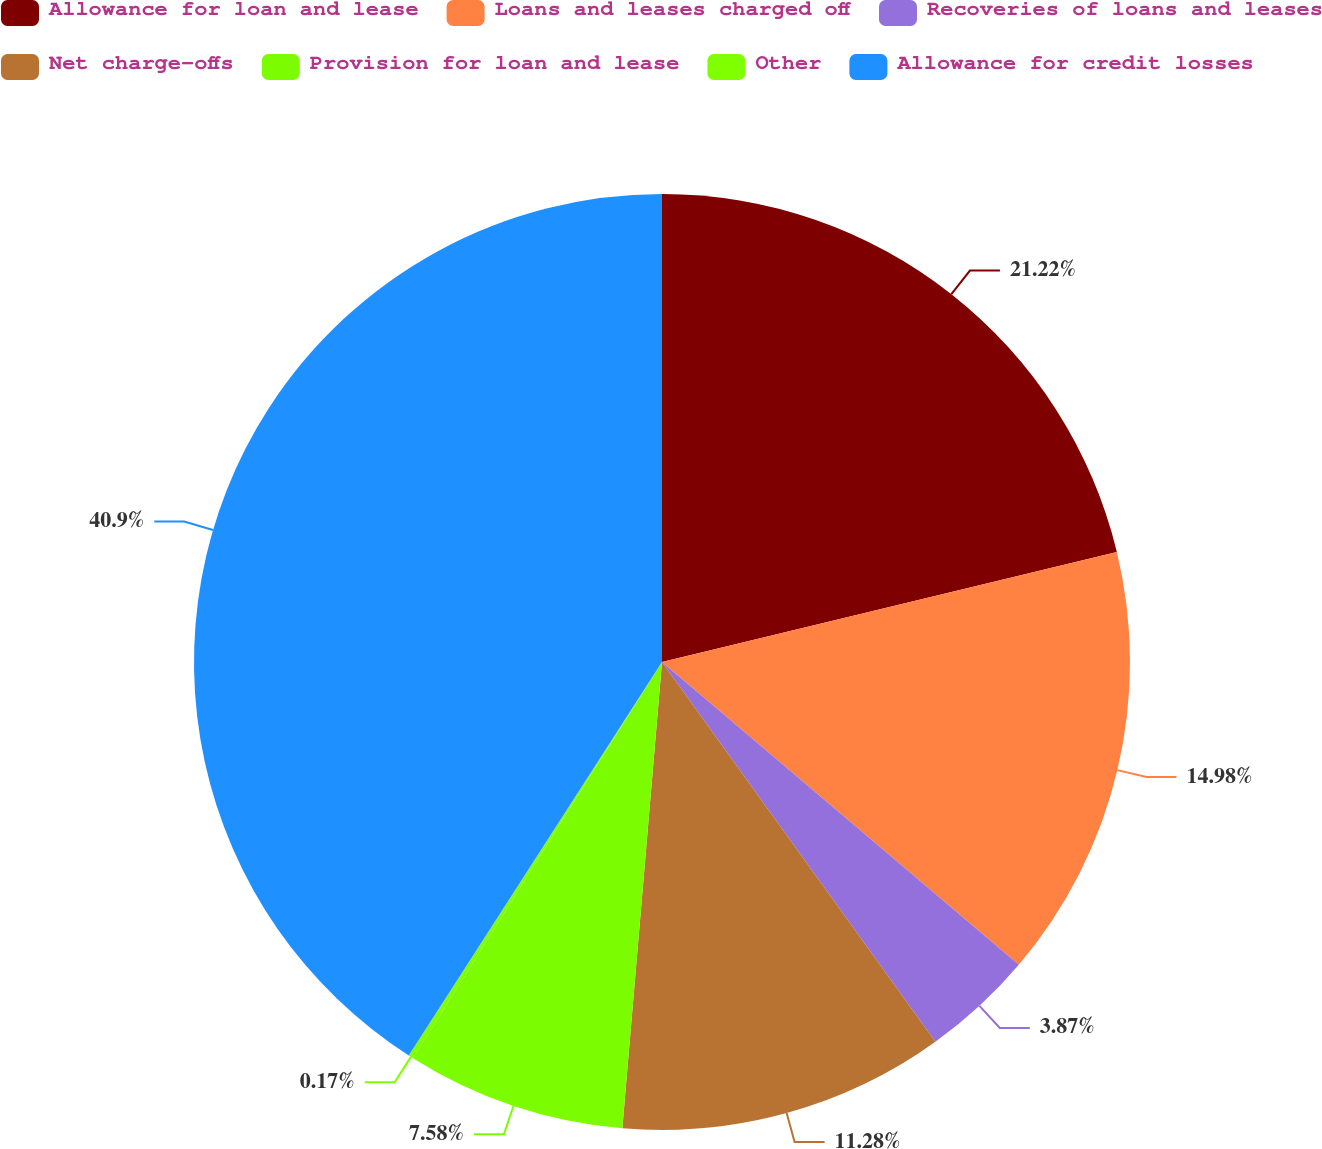Convert chart to OTSL. <chart><loc_0><loc_0><loc_500><loc_500><pie_chart><fcel>Allowance for loan and lease<fcel>Loans and leases charged off<fcel>Recoveries of loans and leases<fcel>Net charge-offs<fcel>Provision for loan and lease<fcel>Other<fcel>Allowance for credit losses<nl><fcel>21.22%<fcel>14.98%<fcel>3.87%<fcel>11.28%<fcel>7.58%<fcel>0.17%<fcel>40.9%<nl></chart> 